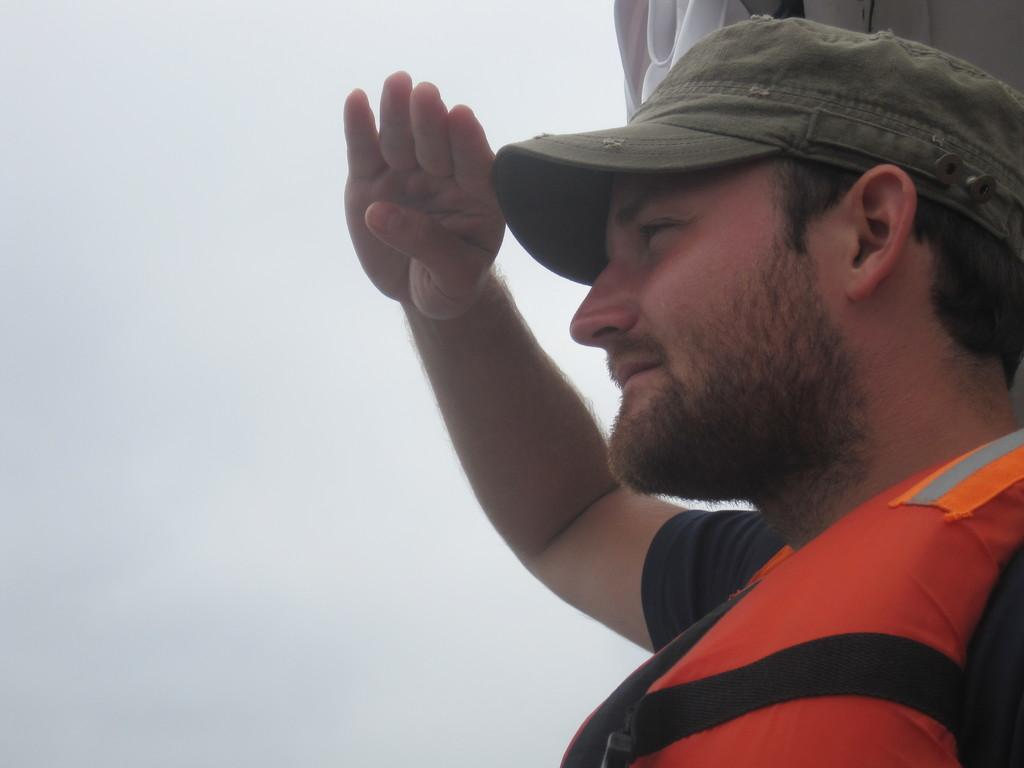Who is present in the image? There is a person in the image. What is the person wearing that might be related to water activities? The person is wearing a life jacket. What type of headwear is the person wearing? The person is wearing a cap. What action is the person performing in the image? The person is saluting. On which side of the image is the person located? The person is on the right side of the image. What can be observed about the sky in the background of the image? The sky in the background of the image is cloudy. What type of rose can be seen in the person's hand in the image? There is no rose present in the image; the person is wearing a life jacket and a cap, and they are saluting. Is the scene taking place during the night in the image? No, the sky in the background of the image is cloudy, but it does not indicate that the scene is taking place during the night. 